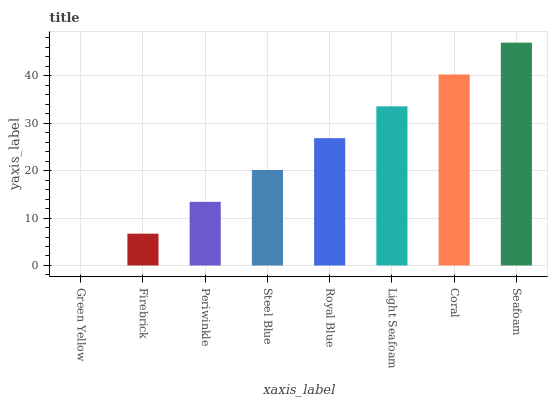Is Firebrick the minimum?
Answer yes or no. No. Is Firebrick the maximum?
Answer yes or no. No. Is Firebrick greater than Green Yellow?
Answer yes or no. Yes. Is Green Yellow less than Firebrick?
Answer yes or no. Yes. Is Green Yellow greater than Firebrick?
Answer yes or no. No. Is Firebrick less than Green Yellow?
Answer yes or no. No. Is Royal Blue the high median?
Answer yes or no. Yes. Is Steel Blue the low median?
Answer yes or no. Yes. Is Firebrick the high median?
Answer yes or no. No. Is Seafoam the low median?
Answer yes or no. No. 